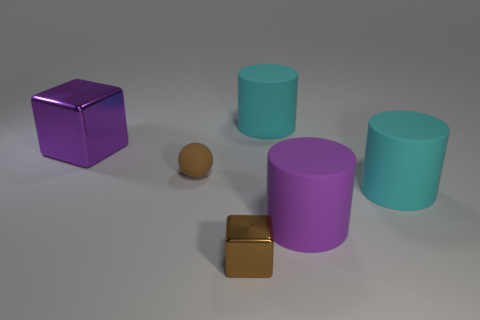Add 4 brown shiny blocks. How many objects exist? 10 Subtract all spheres. How many objects are left? 5 Add 5 small metal cubes. How many small metal cubes are left? 6 Add 3 brown matte balls. How many brown matte balls exist? 4 Subtract 0 cyan balls. How many objects are left? 6 Subtract all purple shiny objects. Subtract all red shiny balls. How many objects are left? 5 